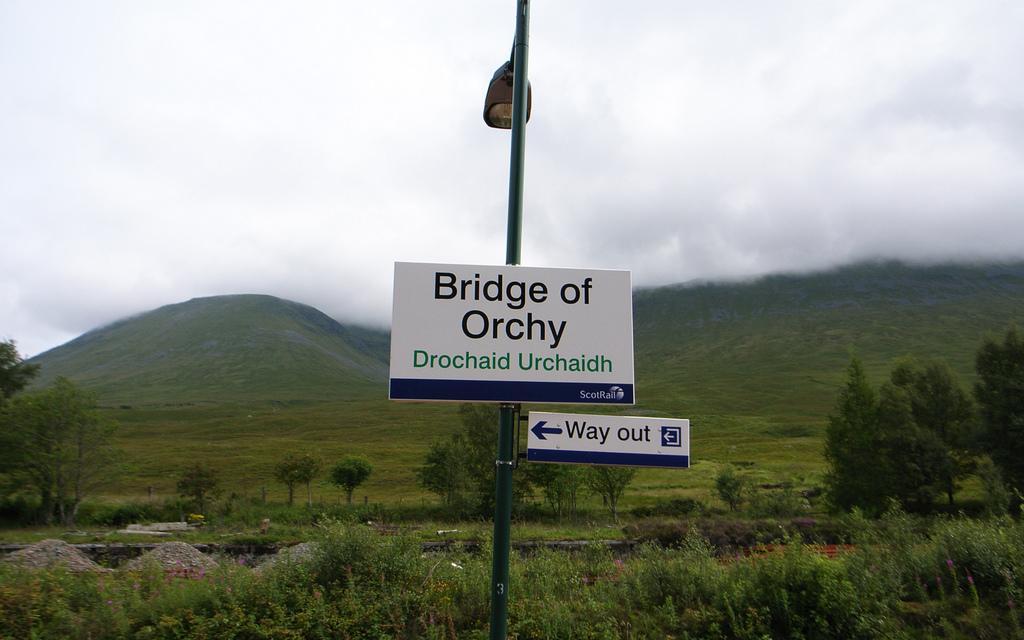Could you give a brief overview of what you see in this image? In this picture I can observe two boards fixed to the pole in the middle of the picture. In the bottom of the picture I can observe some plants on the ground. In the background there are hills and some clouds in the sky. 